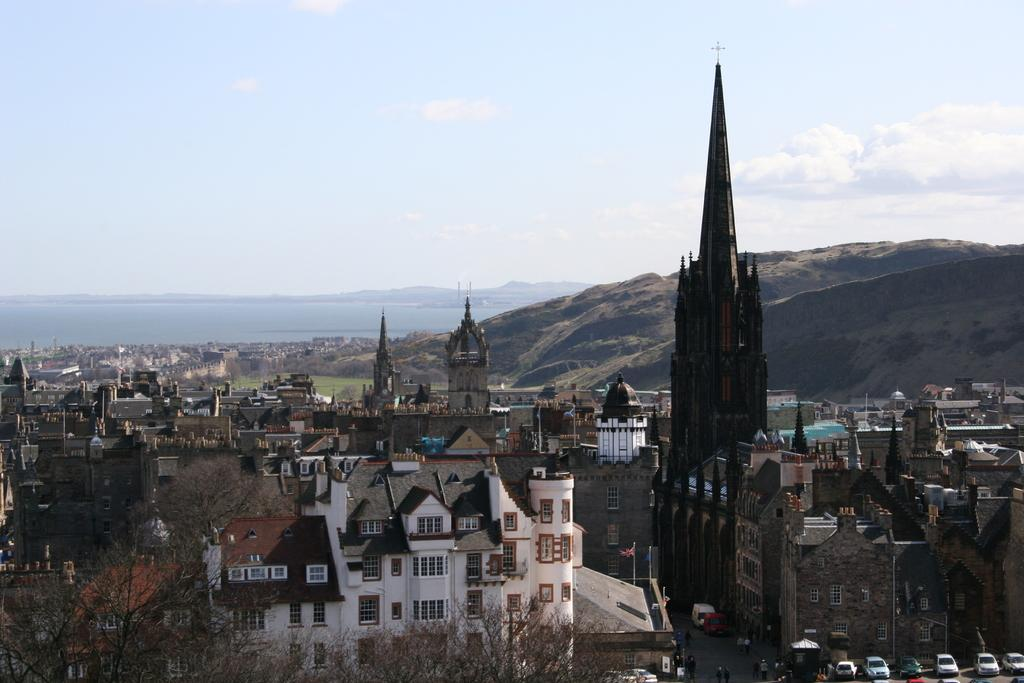What is the primary element visible in the image? There is water in the image. What type of structures can be seen in the image? There are buildings in the image. What type of vegetation is present in the image? There are trees in the image. What type of geographical feature is visible in the image? There are hills in the image. What type of berry is growing on the hills in the image? There is no mention of berries or any type of plant life growing on the hills in the image. 